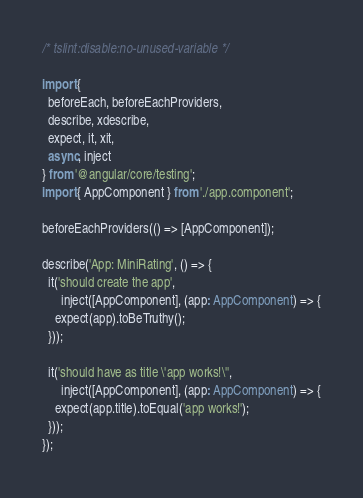<code> <loc_0><loc_0><loc_500><loc_500><_TypeScript_>/* tslint:disable:no-unused-variable */

import {
  beforeEach, beforeEachProviders,
  describe, xdescribe,
  expect, it, xit,
  async, inject
} from '@angular/core/testing';
import { AppComponent } from './app.component';

beforeEachProviders(() => [AppComponent]);

describe('App: MiniRating', () => {
  it('should create the app',
      inject([AppComponent], (app: AppComponent) => {
    expect(app).toBeTruthy();
  }));

  it('should have as title \'app works!\'',
      inject([AppComponent], (app: AppComponent) => {
    expect(app.title).toEqual('app works!');
  }));
});
</code> 